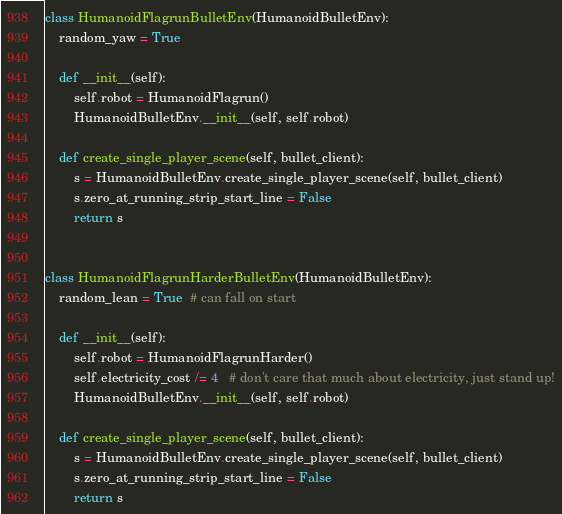<code> <loc_0><loc_0><loc_500><loc_500><_Python_>class HumanoidFlagrunBulletEnv(HumanoidBulletEnv):
    random_yaw = True

    def __init__(self):
        self.robot = HumanoidFlagrun()
        HumanoidBulletEnv.__init__(self, self.robot)

    def create_single_player_scene(self, bullet_client):
        s = HumanoidBulletEnv.create_single_player_scene(self, bullet_client)
        s.zero_at_running_strip_start_line = False
        return s


class HumanoidFlagrunHarderBulletEnv(HumanoidBulletEnv):
    random_lean = True  # can fall on start

    def __init__(self):
        self.robot = HumanoidFlagrunHarder()
        self.electricity_cost /= 4   # don't care that much about electricity, just stand up!
        HumanoidBulletEnv.__init__(self, self.robot)

    def create_single_player_scene(self, bullet_client):
        s = HumanoidBulletEnv.create_single_player_scene(self, bullet_client)
        s.zero_at_running_strip_start_line = False
        return s
</code> 